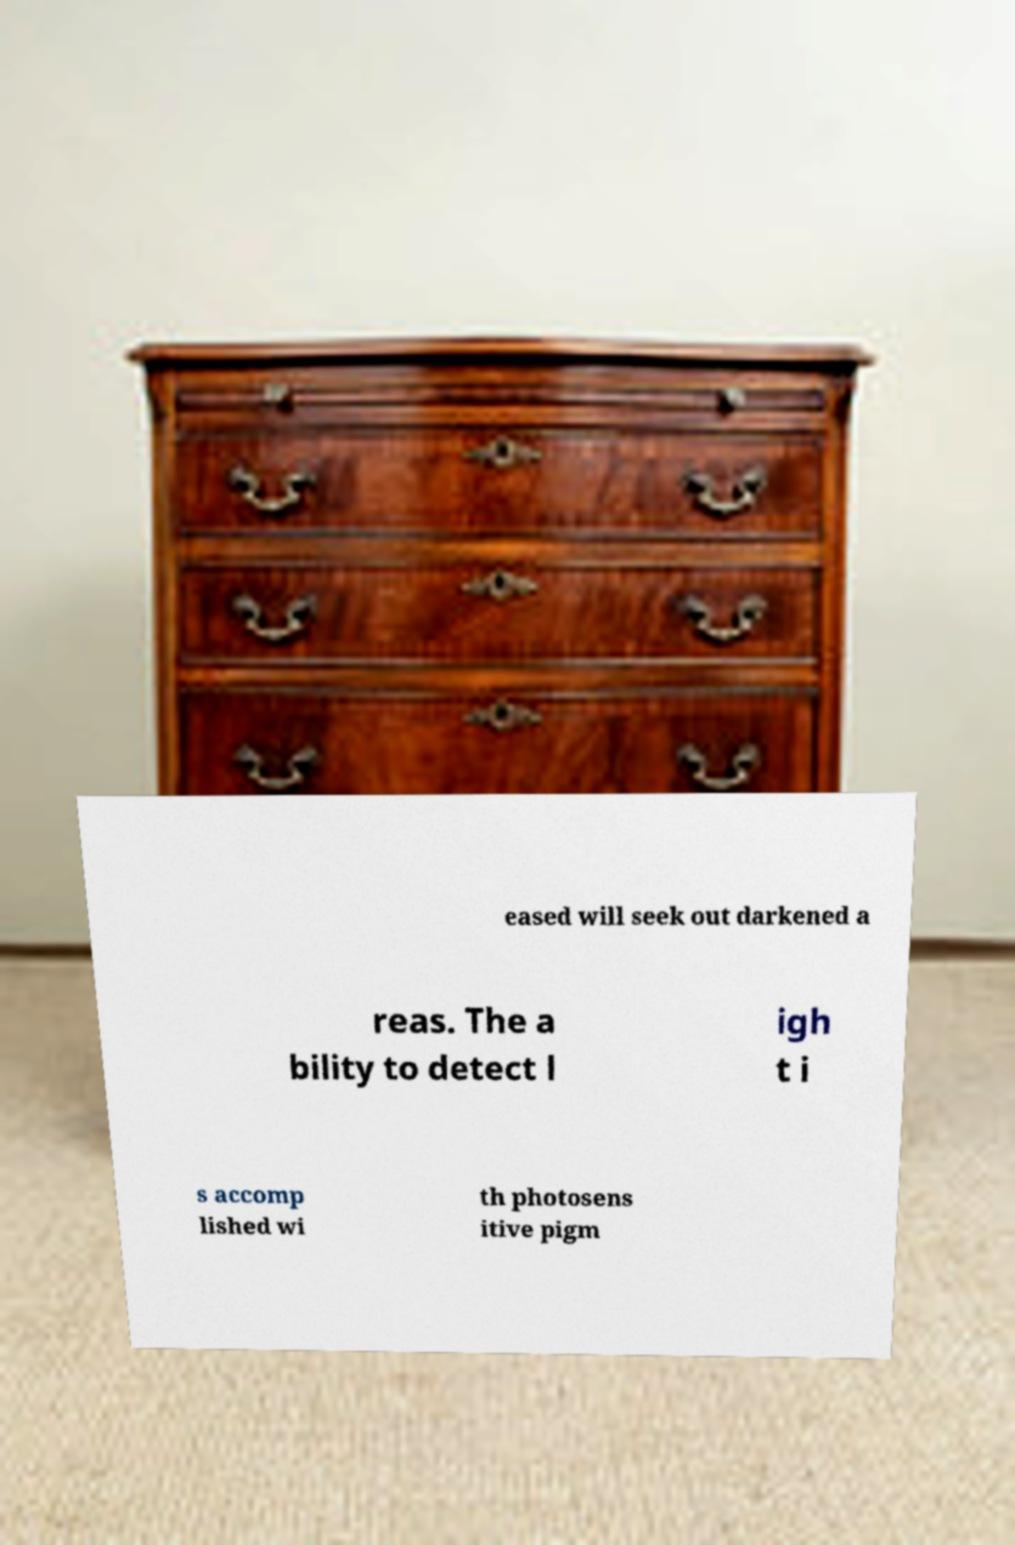For documentation purposes, I need the text within this image transcribed. Could you provide that? eased will seek out darkened a reas. The a bility to detect l igh t i s accomp lished wi th photosens itive pigm 